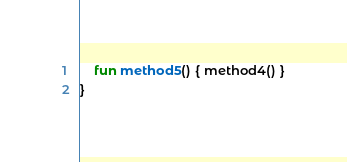Convert code to text. <code><loc_0><loc_0><loc_500><loc_500><_Kotlin_>    fun method5() { method4() }
}
</code> 